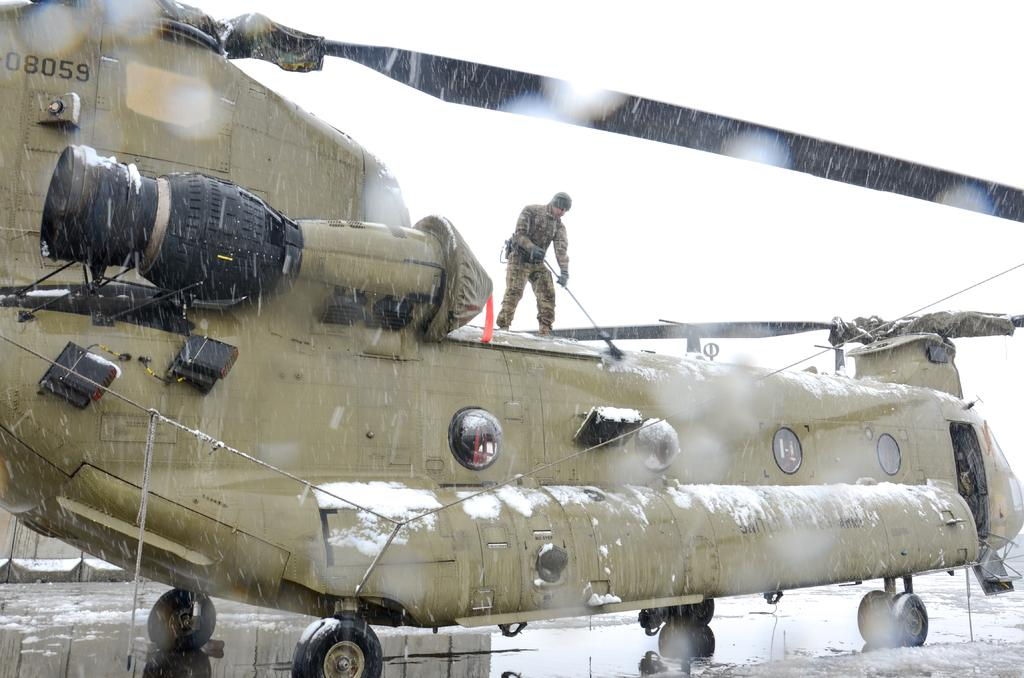Provide a one-sentence caption for the provided image. The numbers on the top of the helicopter read 08059. 